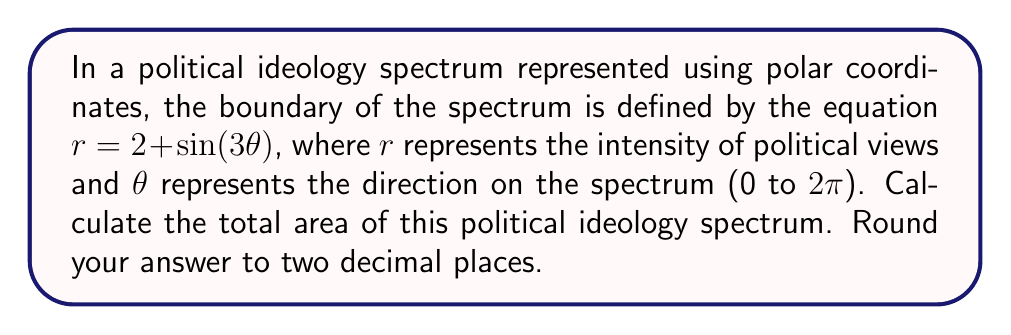Teach me how to tackle this problem. To solve this problem, we need to use the formula for the area of a region in polar coordinates:

$$A = \frac{1}{2} \int_{0}^{2\pi} r^2 d\theta$$

Here's how we proceed:

1) Our equation is $r = 2 + \sin(3\theta)$. We need to square this:

   $r^2 = (2 + \sin(3\theta))^2 = 4 + 4\sin(3\theta) + \sin^2(3\theta)$

2) Now we can set up our integral:

   $$A = \frac{1}{2} \int_{0}^{2\pi} (4 + 4\sin(3\theta) + \sin^2(3\theta)) d\theta$$

3) Let's integrate each term separately:

   a) $\int_{0}^{2\pi} 4 d\theta = 4\theta \big|_{0}^{2\pi} = 8\pi$

   b) $\int_{0}^{2\pi} 4\sin(3\theta) d\theta = -\frac{4}{3}\cos(3\theta) \big|_{0}^{2\pi} = 0$

   c) For $\int_{0}^{2\pi} \sin^2(3\theta) d\theta$, we can use the identity $\sin^2 x = \frac{1}{2}(1 - \cos(2x))$:
      
      $\int_{0}^{2\pi} \sin^2(3\theta) d\theta = \int_{0}^{2\pi} \frac{1}{2}(1 - \cos(6\theta)) d\theta$
      
      $= \frac{1}{2}\theta - \frac{1}{12}\sin(6\theta) \big|_{0}^{2\pi} = \pi$

4) Adding these results:

   $A = \frac{1}{2}(8\pi + 0 + \pi) = \frac{9\pi}{2}$

5) Converting to a decimal and rounding to two places:

   $\frac{9\pi}{2} \approx 14.14$
Answer: 14.14 square units 